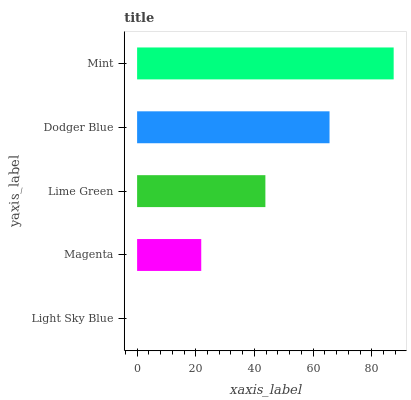Is Light Sky Blue the minimum?
Answer yes or no. Yes. Is Mint the maximum?
Answer yes or no. Yes. Is Magenta the minimum?
Answer yes or no. No. Is Magenta the maximum?
Answer yes or no. No. Is Magenta greater than Light Sky Blue?
Answer yes or no. Yes. Is Light Sky Blue less than Magenta?
Answer yes or no. Yes. Is Light Sky Blue greater than Magenta?
Answer yes or no. No. Is Magenta less than Light Sky Blue?
Answer yes or no. No. Is Lime Green the high median?
Answer yes or no. Yes. Is Lime Green the low median?
Answer yes or no. Yes. Is Dodger Blue the high median?
Answer yes or no. No. Is Mint the low median?
Answer yes or no. No. 